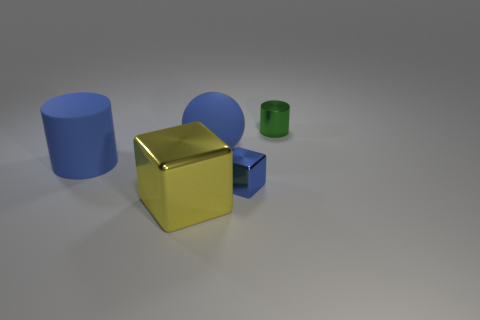Add 1 small blue metal objects. How many objects exist? 6 Subtract all cylinders. How many objects are left? 3 Subtract all large purple metal balls. Subtract all cylinders. How many objects are left? 3 Add 2 small blue shiny objects. How many small blue shiny objects are left? 3 Add 5 small blue blocks. How many small blue blocks exist? 6 Subtract 0 yellow balls. How many objects are left? 5 